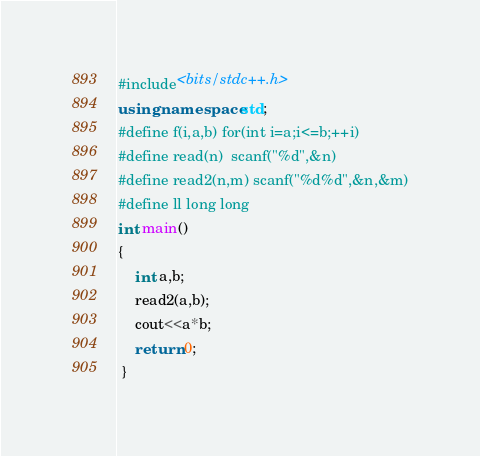Convert code to text. <code><loc_0><loc_0><loc_500><loc_500><_C++_>#include<bits/stdc++.h>
using namespace std;
#define f(i,a,b) for(int i=a;i<=b;++i)
#define read(n)  scanf("%d",&n)
#define read2(n,m) scanf("%d%d",&n,&m)
#define ll long long 
int main()
{
	int a,b;
	read2(a,b);
	cout<<a*b;
	return 0;
 } </code> 